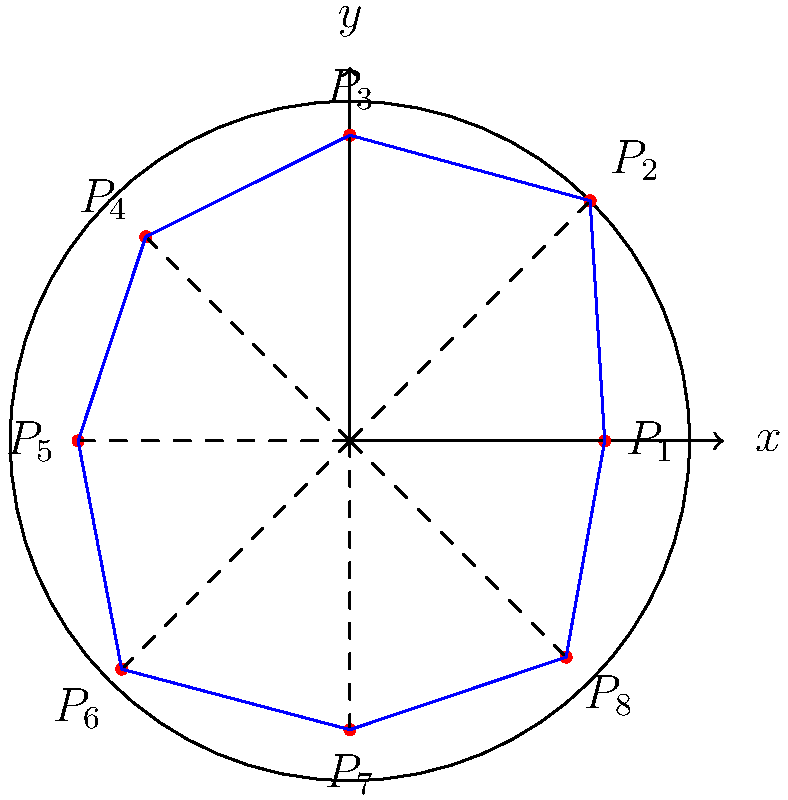You're considering purchasing a uniquely shaped lot for your future home. The lot's boundary is represented by the blue lines in the polar coordinate system shown above. Given that the coordinates of the vertices $P_1$ to $P_8$ are:

$P_1(1.5, 0°)$, $P_2(2, 45°)$, $P_3(1.8, 90°)$, $P_4(1.7, 135°)$, 
$P_5(1.6, 180°)$, $P_6(1.9, 225°)$, $P_7(1.7, 270°)$, $P_8(1.8, 315°)$

Calculate the perimeter of the lot to the nearest foot. (Use $\pi \approx 3.14$ for calculations) To find the perimeter, we need to calculate the distance between each consecutive pair of points and sum them up. We can use the formula for the distance between two points in polar coordinates:

$$d = \sqrt{r_1^2 + r_2^2 - 2r_1r_2\cos(\theta_2 - \theta_1)}$$

Let's calculate each segment:

1) $P_1$ to $P_2$: 
   $$d_{12} = \sqrt{1.5^2 + 2^2 - 2(1.5)(2)\cos(45°)} \approx 0.765$$

2) $P_2$ to $P_3$: 
   $$d_{23} = \sqrt{2^2 + 1.8^2 - 2(2)(1.8)\cos(45°)} \approx 0.404$$

3) $P_3$ to $P_4$: 
   $$d_{34} = \sqrt{1.8^2 + 1.7^2 - 2(1.8)(1.7)\cos(45°)} \approx 0.332$$

4) $P_4$ to $P_5$: 
   $$d_{45} = \sqrt{1.7^2 + 1.6^2 - 2(1.7)(1.6)\cos(45°)} \approx 0.332$$

5) $P_5$ to $P_6$: 
   $$d_{56} = \sqrt{1.6^2 + 1.9^2 - 2(1.6)(1.9)\cos(45°)} \approx 0.612$$

6) $P_6$ to $P_7$: 
   $$d_{67} = \sqrt{1.9^2 + 1.7^2 - 2(1.9)(1.7)\cos(45°)} \approx 0.404$$

7) $P_7$ to $P_8$: 
   $$d_{78} = \sqrt{1.7^2 + 1.8^2 - 2(1.7)(1.8)\cos(45°)} \approx 0.332$$

8) $P_8$ to $P_1$: 
   $$d_{81} = \sqrt{1.8^2 + 1.5^2 - 2(1.8)(1.5)\cos(45°)} \approx 0.612$$

Sum up all distances:
$$\text{Perimeter} = 0.765 + 0.404 + 0.332 + 0.332 + 0.612 + 0.404 + 0.332 + 0.612 = 3.793$$

Converting to feet and rounding to the nearest foot:
$$3.793 * 2 \approx 7.586 \text{ feet} \approx 8 \text{ feet}$$

Note: We multiply by 2 because the radius in the diagram represents 1 unit, which we assume to be 1 foot.
Answer: 8 feet 